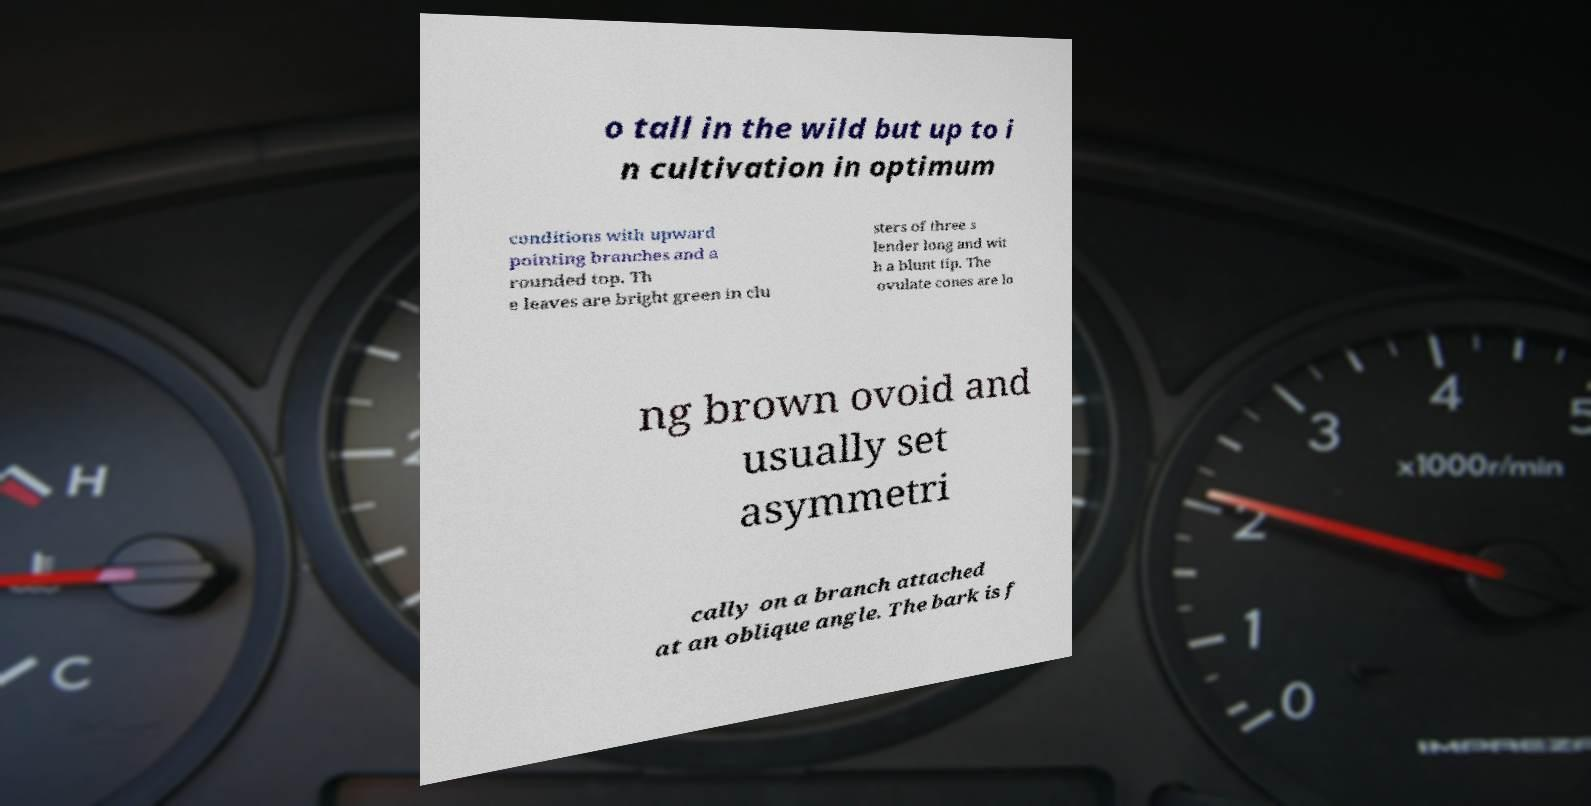There's text embedded in this image that I need extracted. Can you transcribe it verbatim? o tall in the wild but up to i n cultivation in optimum conditions with upward pointing branches and a rounded top. Th e leaves are bright green in clu sters of three s lender long and wit h a blunt tip. The ovulate cones are lo ng brown ovoid and usually set asymmetri cally on a branch attached at an oblique angle. The bark is f 